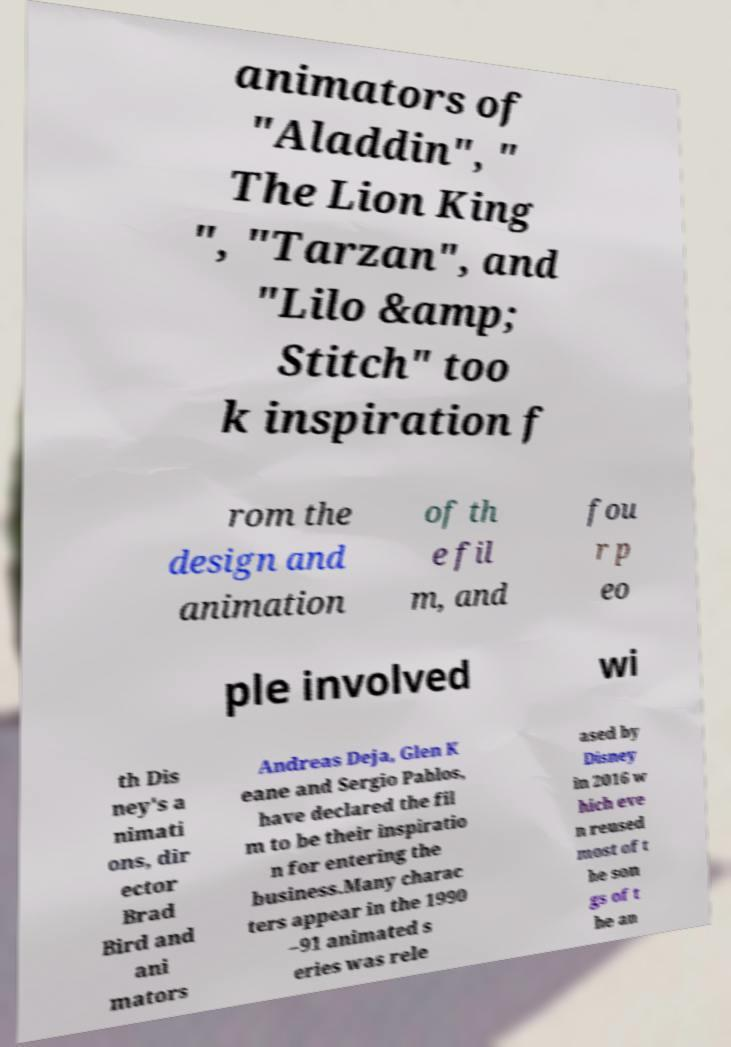For documentation purposes, I need the text within this image transcribed. Could you provide that? animators of "Aladdin", " The Lion King ", "Tarzan", and "Lilo &amp; Stitch" too k inspiration f rom the design and animation of th e fil m, and fou r p eo ple involved wi th Dis ney's a nimati ons, dir ector Brad Bird and ani mators Andreas Deja, Glen K eane and Sergio Pablos, have declared the fil m to be their inspiratio n for entering the business.Many charac ters appear in the 1990 –91 animated s eries was rele ased by Disney in 2016 w hich eve n reused most of t he son gs of t he an 